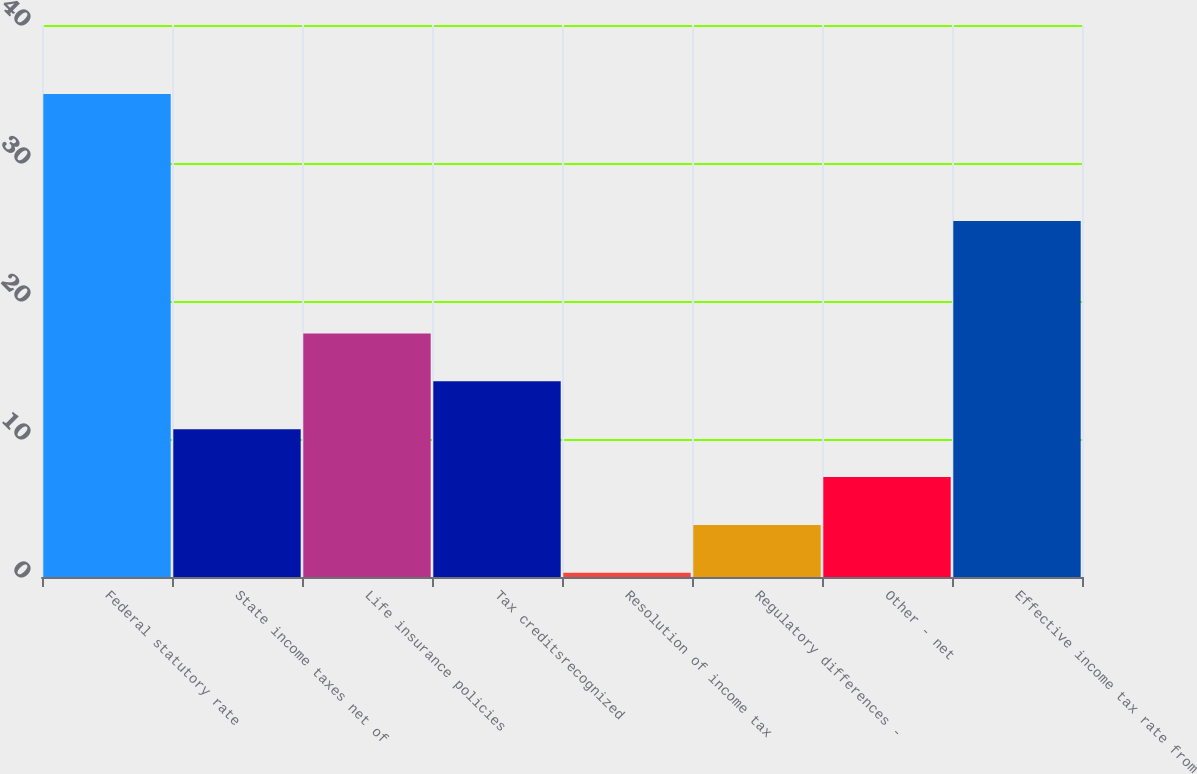Convert chart to OTSL. <chart><loc_0><loc_0><loc_500><loc_500><bar_chart><fcel>Federal statutory rate<fcel>State income taxes net of<fcel>Life insurance policies<fcel>Tax creditsrecognized<fcel>Resolution of income tax<fcel>Regulatory differences -<fcel>Other - net<fcel>Effective income tax rate from<nl><fcel>35<fcel>10.71<fcel>17.65<fcel>14.18<fcel>0.3<fcel>3.77<fcel>7.24<fcel>25.8<nl></chart> 